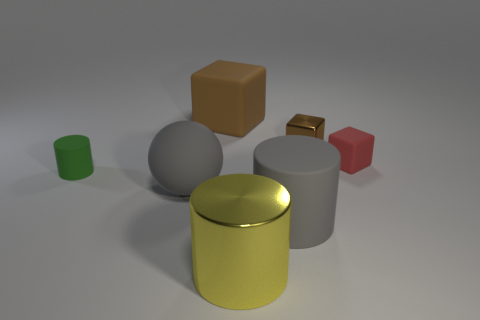Add 2 small brown metal objects. How many objects exist? 9 Subtract all spheres. How many objects are left? 6 Subtract 0 cyan cubes. How many objects are left? 7 Subtract all red rubber cubes. Subtract all green matte things. How many objects are left? 5 Add 1 small brown cubes. How many small brown cubes are left? 2 Add 4 large brown blocks. How many large brown blocks exist? 5 